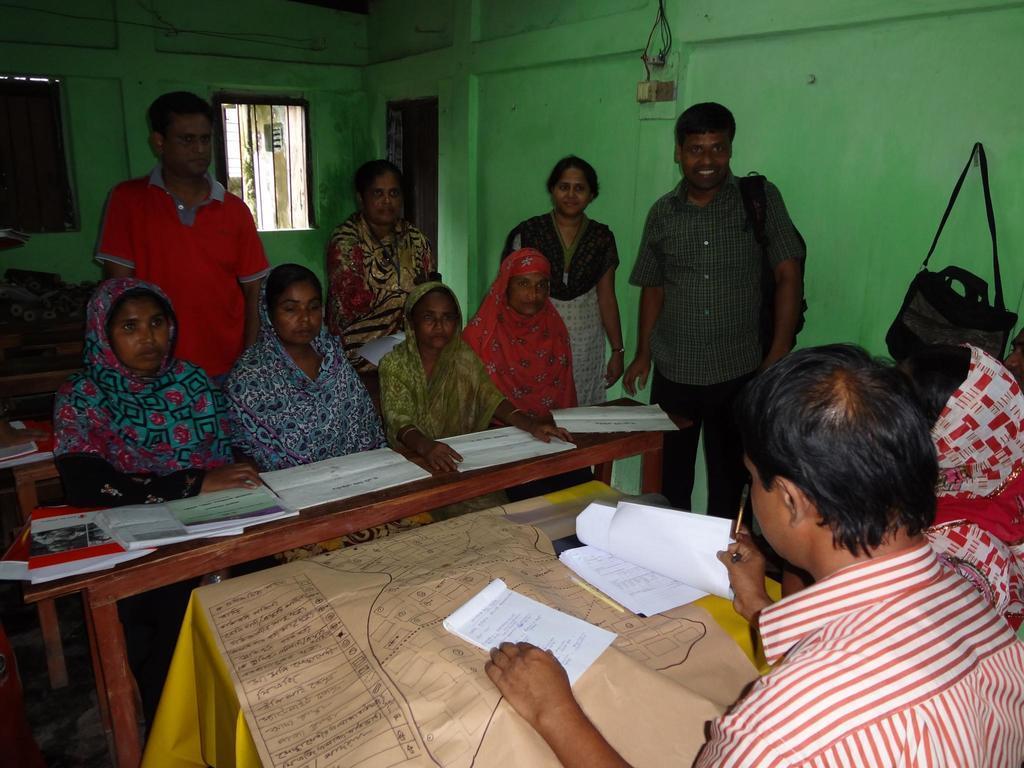Describe this image in one or two sentences. On the right side a man is holding the papers in his hands, on the left side four women are sitting on the bench and looking at this side. Here a man is standing and smiling. 